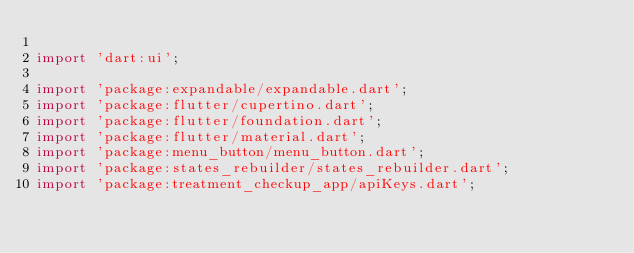Convert code to text. <code><loc_0><loc_0><loc_500><loc_500><_Dart_>
import 'dart:ui';

import 'package:expandable/expandable.dart';
import 'package:flutter/cupertino.dart';
import 'package:flutter/foundation.dart';
import 'package:flutter/material.dart';
import 'package:menu_button/menu_button.dart';
import 'package:states_rebuilder/states_rebuilder.dart';
import 'package:treatment_checkup_app/apiKeys.dart';</code> 